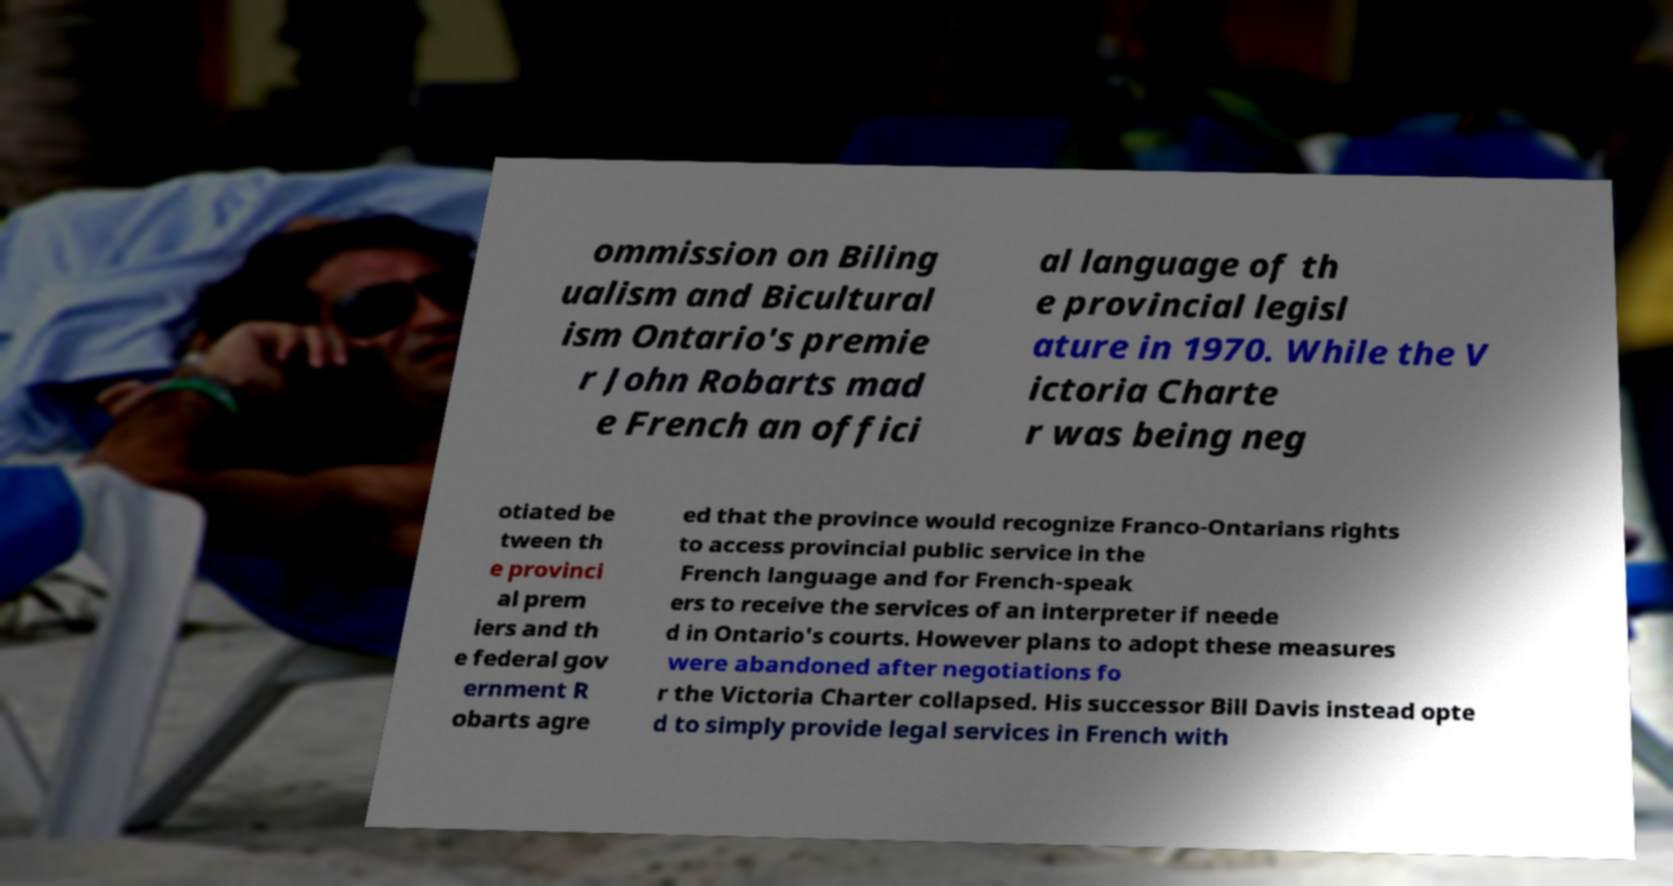For documentation purposes, I need the text within this image transcribed. Could you provide that? ommission on Biling ualism and Bicultural ism Ontario's premie r John Robarts mad e French an offici al language of th e provincial legisl ature in 1970. While the V ictoria Charte r was being neg otiated be tween th e provinci al prem iers and th e federal gov ernment R obarts agre ed that the province would recognize Franco-Ontarians rights to access provincial public service in the French language and for French-speak ers to receive the services of an interpreter if neede d in Ontario's courts. However plans to adopt these measures were abandoned after negotiations fo r the Victoria Charter collapsed. His successor Bill Davis instead opte d to simply provide legal services in French with 